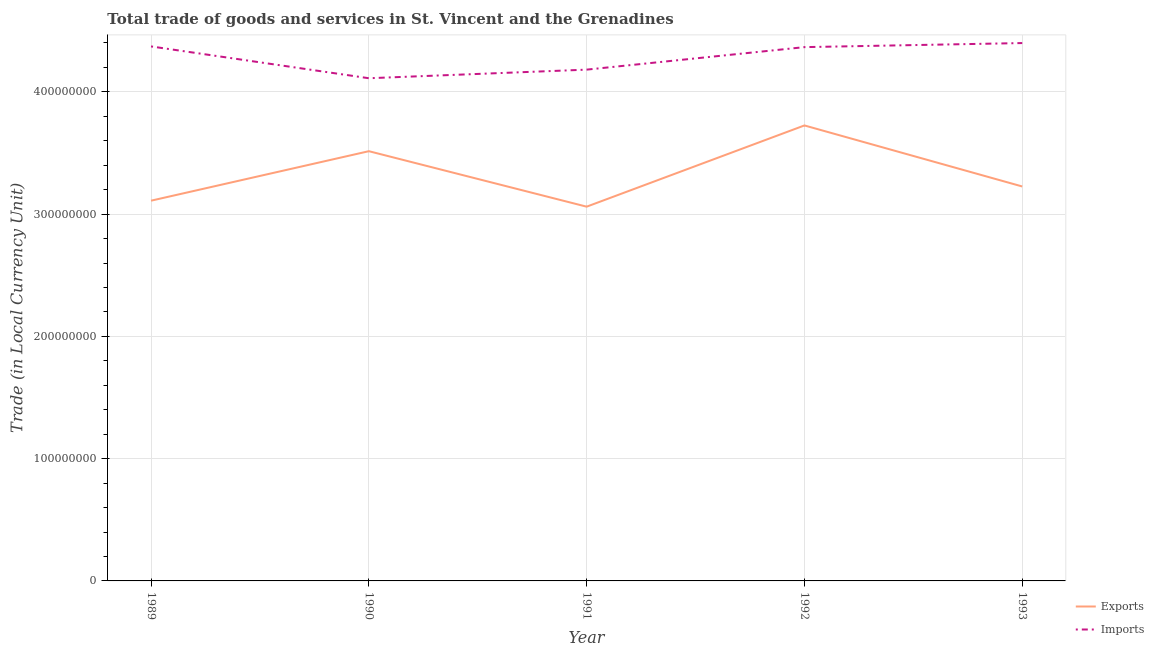How many different coloured lines are there?
Make the answer very short. 2. Is the number of lines equal to the number of legend labels?
Offer a terse response. Yes. What is the imports of goods and services in 1990?
Offer a terse response. 4.11e+08. Across all years, what is the maximum imports of goods and services?
Ensure brevity in your answer.  4.40e+08. Across all years, what is the minimum imports of goods and services?
Offer a terse response. 4.11e+08. In which year was the imports of goods and services maximum?
Make the answer very short. 1993. What is the total imports of goods and services in the graph?
Provide a short and direct response. 2.14e+09. What is the difference between the imports of goods and services in 1989 and that in 1993?
Your response must be concise. -2.75e+06. What is the difference between the imports of goods and services in 1993 and the export of goods and services in 1992?
Ensure brevity in your answer.  6.74e+07. What is the average export of goods and services per year?
Give a very brief answer. 3.33e+08. In the year 1990, what is the difference between the imports of goods and services and export of goods and services?
Give a very brief answer. 5.97e+07. In how many years, is the export of goods and services greater than 400000000 LCU?
Provide a succinct answer. 0. What is the ratio of the export of goods and services in 1989 to that in 1992?
Keep it short and to the point. 0.83. Is the export of goods and services in 1990 less than that in 1991?
Keep it short and to the point. No. Is the difference between the export of goods and services in 1989 and 1992 greater than the difference between the imports of goods and services in 1989 and 1992?
Keep it short and to the point. No. What is the difference between the highest and the second highest imports of goods and services?
Offer a terse response. 2.75e+06. What is the difference between the highest and the lowest imports of goods and services?
Give a very brief answer. 2.88e+07. In how many years, is the imports of goods and services greater than the average imports of goods and services taken over all years?
Provide a succinct answer. 3. Does the imports of goods and services monotonically increase over the years?
Your answer should be very brief. No. Is the export of goods and services strictly greater than the imports of goods and services over the years?
Your answer should be very brief. No. Is the imports of goods and services strictly less than the export of goods and services over the years?
Your answer should be very brief. No. How many lines are there?
Offer a very short reply. 2. What is the difference between two consecutive major ticks on the Y-axis?
Your response must be concise. 1.00e+08. Does the graph contain any zero values?
Your response must be concise. No. Does the graph contain grids?
Give a very brief answer. Yes. Where does the legend appear in the graph?
Offer a terse response. Bottom right. How many legend labels are there?
Your answer should be compact. 2. How are the legend labels stacked?
Give a very brief answer. Vertical. What is the title of the graph?
Make the answer very short. Total trade of goods and services in St. Vincent and the Grenadines. What is the label or title of the X-axis?
Keep it short and to the point. Year. What is the label or title of the Y-axis?
Keep it short and to the point. Trade (in Local Currency Unit). What is the Trade (in Local Currency Unit) in Exports in 1989?
Provide a succinct answer. 3.11e+08. What is the Trade (in Local Currency Unit) in Imports in 1989?
Provide a short and direct response. 4.37e+08. What is the Trade (in Local Currency Unit) of Exports in 1990?
Your response must be concise. 3.51e+08. What is the Trade (in Local Currency Unit) in Imports in 1990?
Ensure brevity in your answer.  4.11e+08. What is the Trade (in Local Currency Unit) of Exports in 1991?
Your answer should be very brief. 3.06e+08. What is the Trade (in Local Currency Unit) of Imports in 1991?
Your answer should be compact. 4.18e+08. What is the Trade (in Local Currency Unit) of Exports in 1992?
Your answer should be very brief. 3.73e+08. What is the Trade (in Local Currency Unit) of Imports in 1992?
Provide a succinct answer. 4.37e+08. What is the Trade (in Local Currency Unit) in Exports in 1993?
Make the answer very short. 3.23e+08. What is the Trade (in Local Currency Unit) in Imports in 1993?
Provide a short and direct response. 4.40e+08. Across all years, what is the maximum Trade (in Local Currency Unit) of Exports?
Give a very brief answer. 3.73e+08. Across all years, what is the maximum Trade (in Local Currency Unit) of Imports?
Your answer should be very brief. 4.40e+08. Across all years, what is the minimum Trade (in Local Currency Unit) of Exports?
Provide a succinct answer. 3.06e+08. Across all years, what is the minimum Trade (in Local Currency Unit) of Imports?
Your answer should be very brief. 4.11e+08. What is the total Trade (in Local Currency Unit) of Exports in the graph?
Make the answer very short. 1.66e+09. What is the total Trade (in Local Currency Unit) of Imports in the graph?
Make the answer very short. 2.14e+09. What is the difference between the Trade (in Local Currency Unit) in Exports in 1989 and that in 1990?
Your answer should be very brief. -4.05e+07. What is the difference between the Trade (in Local Currency Unit) in Imports in 1989 and that in 1990?
Provide a short and direct response. 2.60e+07. What is the difference between the Trade (in Local Currency Unit) in Exports in 1989 and that in 1991?
Your answer should be very brief. 4.90e+06. What is the difference between the Trade (in Local Currency Unit) of Imports in 1989 and that in 1991?
Keep it short and to the point. 1.90e+07. What is the difference between the Trade (in Local Currency Unit) in Exports in 1989 and that in 1992?
Offer a terse response. -6.15e+07. What is the difference between the Trade (in Local Currency Unit) of Imports in 1989 and that in 1992?
Offer a very short reply. 5.80e+05. What is the difference between the Trade (in Local Currency Unit) of Exports in 1989 and that in 1993?
Ensure brevity in your answer.  -1.16e+07. What is the difference between the Trade (in Local Currency Unit) in Imports in 1989 and that in 1993?
Offer a very short reply. -2.75e+06. What is the difference between the Trade (in Local Currency Unit) in Exports in 1990 and that in 1991?
Offer a terse response. 4.54e+07. What is the difference between the Trade (in Local Currency Unit) of Imports in 1990 and that in 1991?
Offer a terse response. -7.03e+06. What is the difference between the Trade (in Local Currency Unit) of Exports in 1990 and that in 1992?
Your answer should be compact. -2.11e+07. What is the difference between the Trade (in Local Currency Unit) in Imports in 1990 and that in 1992?
Provide a succinct answer. -2.54e+07. What is the difference between the Trade (in Local Currency Unit) of Exports in 1990 and that in 1993?
Give a very brief answer. 2.88e+07. What is the difference between the Trade (in Local Currency Unit) in Imports in 1990 and that in 1993?
Provide a succinct answer. -2.88e+07. What is the difference between the Trade (in Local Currency Unit) of Exports in 1991 and that in 1992?
Your response must be concise. -6.64e+07. What is the difference between the Trade (in Local Currency Unit) of Imports in 1991 and that in 1992?
Keep it short and to the point. -1.84e+07. What is the difference between the Trade (in Local Currency Unit) of Exports in 1991 and that in 1993?
Keep it short and to the point. -1.65e+07. What is the difference between the Trade (in Local Currency Unit) of Imports in 1991 and that in 1993?
Your answer should be very brief. -2.17e+07. What is the difference between the Trade (in Local Currency Unit) in Exports in 1992 and that in 1993?
Your response must be concise. 4.99e+07. What is the difference between the Trade (in Local Currency Unit) in Imports in 1992 and that in 1993?
Make the answer very short. -3.33e+06. What is the difference between the Trade (in Local Currency Unit) in Exports in 1989 and the Trade (in Local Currency Unit) in Imports in 1990?
Your answer should be very brief. -1.00e+08. What is the difference between the Trade (in Local Currency Unit) of Exports in 1989 and the Trade (in Local Currency Unit) of Imports in 1991?
Your response must be concise. -1.07e+08. What is the difference between the Trade (in Local Currency Unit) in Exports in 1989 and the Trade (in Local Currency Unit) in Imports in 1992?
Your response must be concise. -1.26e+08. What is the difference between the Trade (in Local Currency Unit) in Exports in 1989 and the Trade (in Local Currency Unit) in Imports in 1993?
Make the answer very short. -1.29e+08. What is the difference between the Trade (in Local Currency Unit) in Exports in 1990 and the Trade (in Local Currency Unit) in Imports in 1991?
Provide a succinct answer. -6.67e+07. What is the difference between the Trade (in Local Currency Unit) of Exports in 1990 and the Trade (in Local Currency Unit) of Imports in 1992?
Keep it short and to the point. -8.51e+07. What is the difference between the Trade (in Local Currency Unit) of Exports in 1990 and the Trade (in Local Currency Unit) of Imports in 1993?
Your answer should be compact. -8.84e+07. What is the difference between the Trade (in Local Currency Unit) in Exports in 1991 and the Trade (in Local Currency Unit) in Imports in 1992?
Provide a succinct answer. -1.30e+08. What is the difference between the Trade (in Local Currency Unit) in Exports in 1991 and the Trade (in Local Currency Unit) in Imports in 1993?
Offer a terse response. -1.34e+08. What is the difference between the Trade (in Local Currency Unit) of Exports in 1992 and the Trade (in Local Currency Unit) of Imports in 1993?
Offer a terse response. -6.74e+07. What is the average Trade (in Local Currency Unit) of Exports per year?
Your answer should be very brief. 3.33e+08. What is the average Trade (in Local Currency Unit) of Imports per year?
Ensure brevity in your answer.  4.29e+08. In the year 1989, what is the difference between the Trade (in Local Currency Unit) of Exports and Trade (in Local Currency Unit) of Imports?
Ensure brevity in your answer.  -1.26e+08. In the year 1990, what is the difference between the Trade (in Local Currency Unit) of Exports and Trade (in Local Currency Unit) of Imports?
Provide a succinct answer. -5.97e+07. In the year 1991, what is the difference between the Trade (in Local Currency Unit) of Exports and Trade (in Local Currency Unit) of Imports?
Make the answer very short. -1.12e+08. In the year 1992, what is the difference between the Trade (in Local Currency Unit) in Exports and Trade (in Local Currency Unit) in Imports?
Your answer should be compact. -6.40e+07. In the year 1993, what is the difference between the Trade (in Local Currency Unit) in Exports and Trade (in Local Currency Unit) in Imports?
Keep it short and to the point. -1.17e+08. What is the ratio of the Trade (in Local Currency Unit) in Exports in 1989 to that in 1990?
Give a very brief answer. 0.88. What is the ratio of the Trade (in Local Currency Unit) of Imports in 1989 to that in 1990?
Your answer should be very brief. 1.06. What is the ratio of the Trade (in Local Currency Unit) of Exports in 1989 to that in 1991?
Make the answer very short. 1.02. What is the ratio of the Trade (in Local Currency Unit) of Imports in 1989 to that in 1991?
Ensure brevity in your answer.  1.05. What is the ratio of the Trade (in Local Currency Unit) in Exports in 1989 to that in 1992?
Keep it short and to the point. 0.83. What is the ratio of the Trade (in Local Currency Unit) in Exports in 1990 to that in 1991?
Ensure brevity in your answer.  1.15. What is the ratio of the Trade (in Local Currency Unit) of Imports in 1990 to that in 1991?
Your answer should be very brief. 0.98. What is the ratio of the Trade (in Local Currency Unit) in Exports in 1990 to that in 1992?
Your response must be concise. 0.94. What is the ratio of the Trade (in Local Currency Unit) of Imports in 1990 to that in 1992?
Your answer should be very brief. 0.94. What is the ratio of the Trade (in Local Currency Unit) of Exports in 1990 to that in 1993?
Keep it short and to the point. 1.09. What is the ratio of the Trade (in Local Currency Unit) in Imports in 1990 to that in 1993?
Make the answer very short. 0.93. What is the ratio of the Trade (in Local Currency Unit) in Exports in 1991 to that in 1992?
Your answer should be compact. 0.82. What is the ratio of the Trade (in Local Currency Unit) in Imports in 1991 to that in 1992?
Offer a terse response. 0.96. What is the ratio of the Trade (in Local Currency Unit) of Exports in 1991 to that in 1993?
Your answer should be compact. 0.95. What is the ratio of the Trade (in Local Currency Unit) in Imports in 1991 to that in 1993?
Provide a short and direct response. 0.95. What is the ratio of the Trade (in Local Currency Unit) in Exports in 1992 to that in 1993?
Your response must be concise. 1.15. What is the difference between the highest and the second highest Trade (in Local Currency Unit) in Exports?
Ensure brevity in your answer.  2.11e+07. What is the difference between the highest and the second highest Trade (in Local Currency Unit) in Imports?
Your answer should be very brief. 2.75e+06. What is the difference between the highest and the lowest Trade (in Local Currency Unit) of Exports?
Offer a terse response. 6.64e+07. What is the difference between the highest and the lowest Trade (in Local Currency Unit) in Imports?
Offer a very short reply. 2.88e+07. 